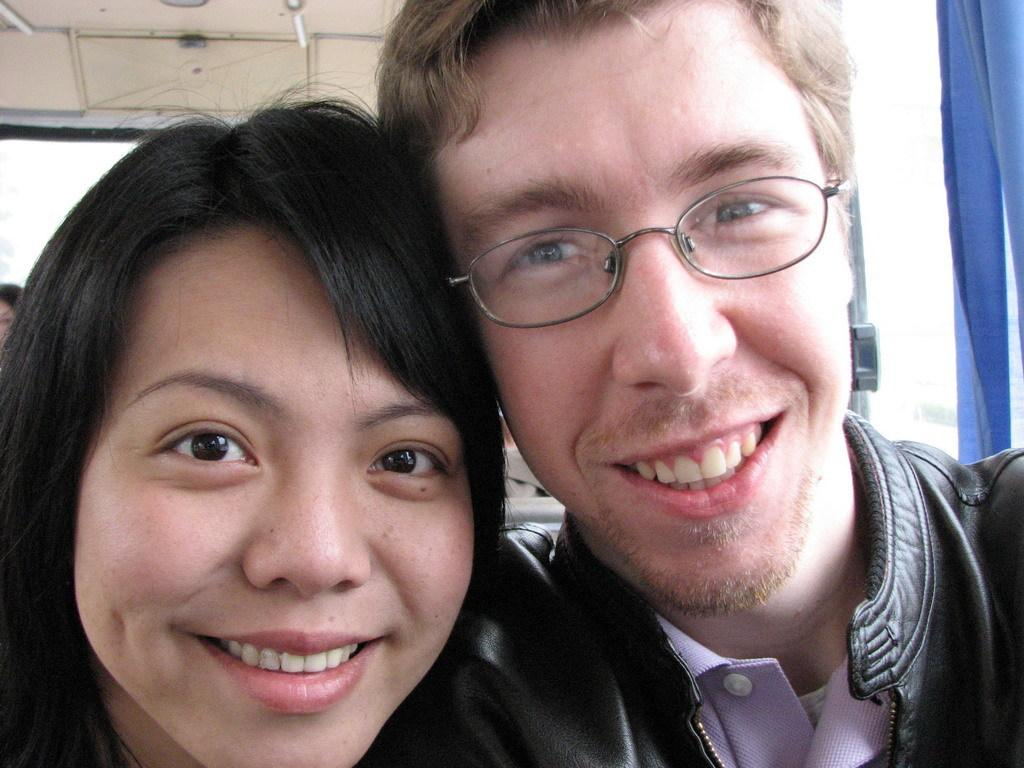Who is on the left side of the image? There is a woman and a man wearing glasses on the left side of the image. What are the expressions of the people in the image? Both the woman and the man are smiling. What color is the object on the right side of the image? There is a blue object on the right side of the image. What is the price of the orange in the image? There is no orange present in the image, so it is not possible to determine its price. 